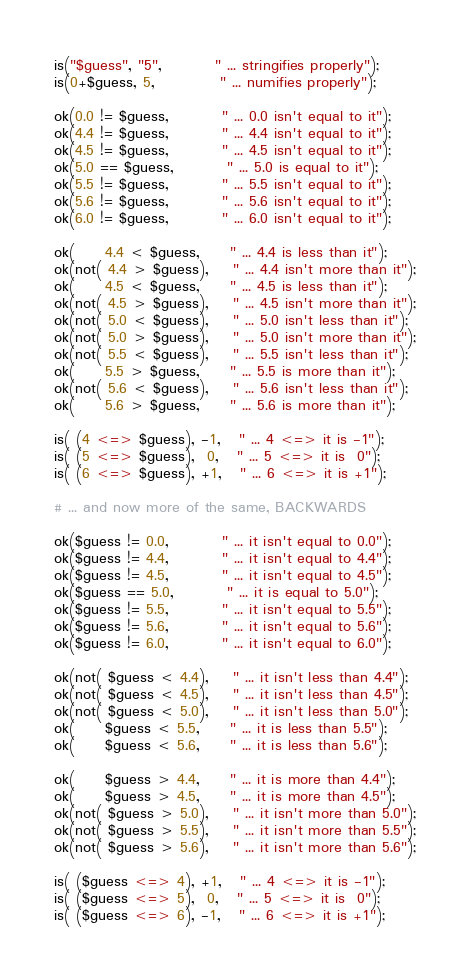<code> <loc_0><loc_0><loc_500><loc_500><_Perl_>is("$guess", "5",         " ... stringifies properly");
is(0+$guess, 5,           " ... numifies properly");

ok(0.0 != $guess,         " ... 0.0 isn't equal to it");
ok(4.4 != $guess,         " ... 4.4 isn't equal to it");
ok(4.5 != $guess,         " ... 4.5 isn't equal to it");
ok(5.0 == $guess,         " ... 5.0 is equal to it");
ok(5.5 != $guess,         " ... 5.5 isn't equal to it");
ok(5.6 != $guess,         " ... 5.6 isn't equal to it");
ok(6.0 != $guess,         " ... 6.0 isn't equal to it");

ok(     4.4 < $guess,     " ... 4.4 is less than it");
ok(not( 4.4 > $guess),    " ... 4.4 isn't more than it");
ok(     4.5 < $guess,     " ... 4.5 is less than it");
ok(not( 4.5 > $guess),    " ... 4.5 isn't more than it");
ok(not( 5.0 < $guess),    " ... 5.0 isn't less than it");
ok(not( 5.0 > $guess),    " ... 5.0 isn't more than it");
ok(not( 5.5 < $guess),    " ... 5.5 isn't less than it");
ok(     5.5 > $guess,     " ... 5.5 is more than it");
ok(not( 5.6 < $guess),    " ... 5.6 isn't less than it");
ok(     5.6 > $guess,     " ... 5.6 is more than it");

is( (4 <=> $guess), -1,   " ... 4 <=> it is -1");
is( (5 <=> $guess),  0,   " ... 5 <=> it is  0");
is( (6 <=> $guess), +1,   " ... 6 <=> it is +1");

# ... and now more of the same, BACKWARDS

ok($guess != 0.0,         " ... it isn't equal to 0.0");
ok($guess != 4.4,         " ... it isn't equal to 4.4");
ok($guess != 4.5,         " ... it isn't equal to 4.5");
ok($guess == 5.0,         " ... it is equal to 5.0");
ok($guess != 5.5,         " ... it isn't equal to 5.5");
ok($guess != 5.6,         " ... it isn't equal to 5.6");
ok($guess != 6.0,         " ... it isn't equal to 6.0");

ok(not( $guess < 4.4),    " ... it isn't less than 4.4");
ok(not( $guess < 4.5),    " ... it isn't less than 4.5");
ok(not( $guess < 5.0),    " ... it isn't less than 5.0");
ok(     $guess < 5.5,     " ... it is less than 5.5");
ok(     $guess < 5.6,     " ... it is less than 5.6");

ok(     $guess > 4.4,     " ... it is more than 4.4");
ok(     $guess > 4.5,     " ... it is more than 4.5");
ok(not( $guess > 5.0),    " ... it isn't more than 5.0");
ok(not( $guess > 5.5),    " ... it isn't more than 5.5");
ok(not( $guess > 5.6),    " ... it isn't more than 5.6");

is( ($guess <=> 4), +1,   " ... 4 <=> it is -1");
is( ($guess <=> 5),  0,   " ... 5 <=> it is  0");
is( ($guess <=> 6), -1,   " ... 6 <=> it is +1");
</code> 